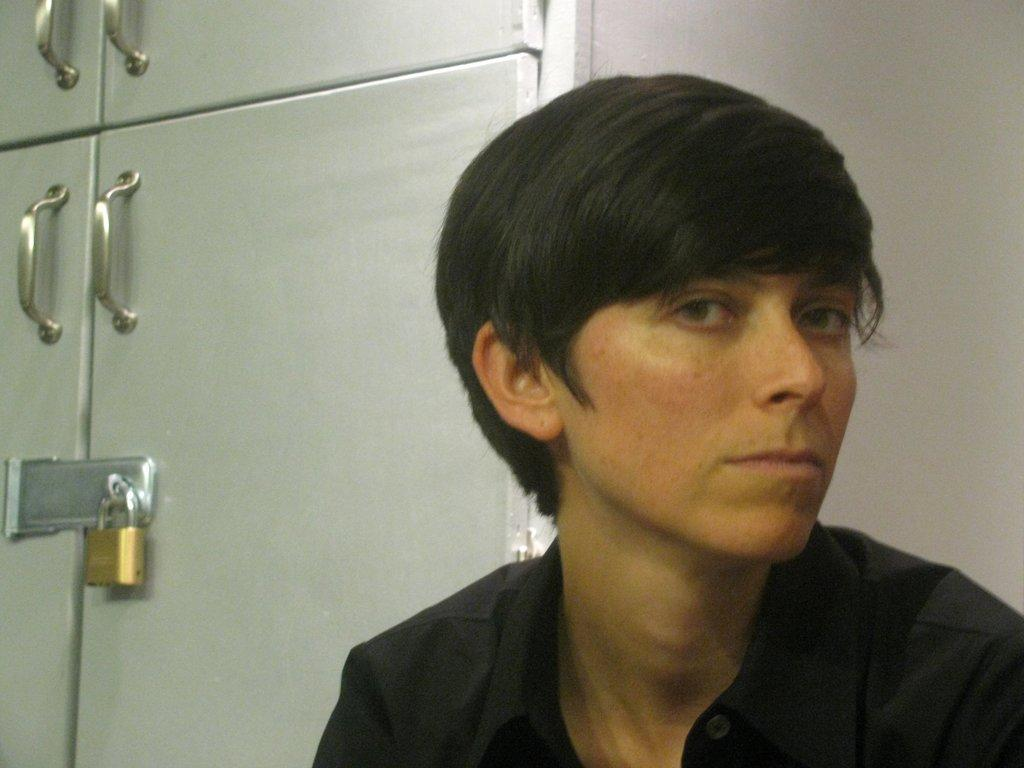Who is the main subject in the image? There is a girl in the image. What is the girl wearing? The girl is wearing a black shirt. What is the girl doing in the image? The girl is looking at the camera. What type of furniture can be seen in the image? There is a white cupboard in the image. What is the status of the cupboard? The cupboard is locked. What color is the wall in the image? There is a white wall in the image. Can you tell me how many times the girl jumps in the image? There is no indication of the girl jumping in the image; she is looking at the camera. What force is applied to the ground by the girl in the image? There is no information about the girl applying force to the ground in the image. 